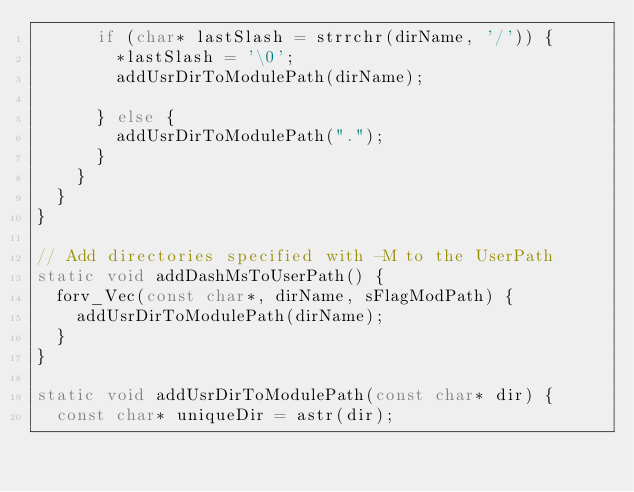Convert code to text. <code><loc_0><loc_0><loc_500><loc_500><_C++_>      if (char* lastSlash = strrchr(dirName, '/')) {
        *lastSlash = '\0';
        addUsrDirToModulePath(dirName);

      } else {
        addUsrDirToModulePath(".");
      }
    }
  }
}

// Add directories specified with -M to the UserPath
static void addDashMsToUserPath() {
  forv_Vec(const char*, dirName, sFlagModPath) {
    addUsrDirToModulePath(dirName);
  }
}

static void addUsrDirToModulePath(const char* dir) {
  const char* uniqueDir = astr(dir);
</code> 